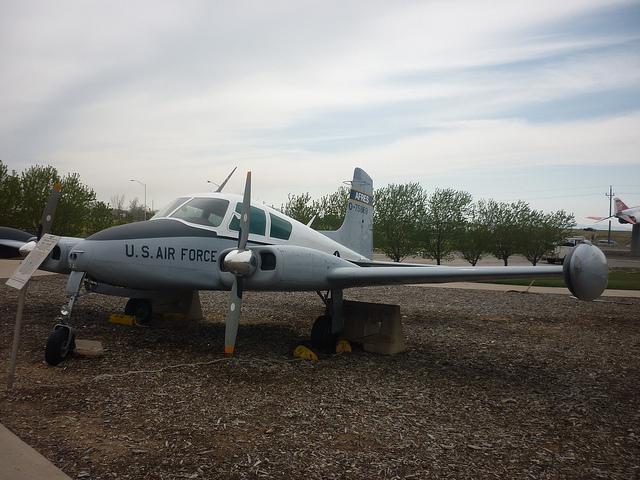How many people are wearing glasses?
Give a very brief answer. 0. 